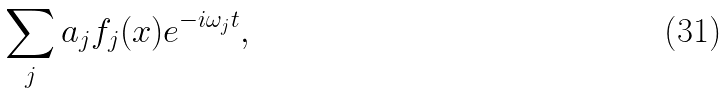Convert formula to latex. <formula><loc_0><loc_0><loc_500><loc_500>\sum _ { j } a _ { j } f _ { j } ( x ) e ^ { - i \omega _ { j } t } ,</formula> 